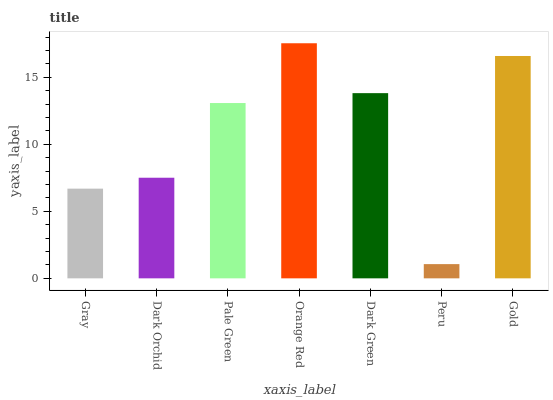Is Peru the minimum?
Answer yes or no. Yes. Is Orange Red the maximum?
Answer yes or no. Yes. Is Dark Orchid the minimum?
Answer yes or no. No. Is Dark Orchid the maximum?
Answer yes or no. No. Is Dark Orchid greater than Gray?
Answer yes or no. Yes. Is Gray less than Dark Orchid?
Answer yes or no. Yes. Is Gray greater than Dark Orchid?
Answer yes or no. No. Is Dark Orchid less than Gray?
Answer yes or no. No. Is Pale Green the high median?
Answer yes or no. Yes. Is Pale Green the low median?
Answer yes or no. Yes. Is Dark Orchid the high median?
Answer yes or no. No. Is Dark Orchid the low median?
Answer yes or no. No. 